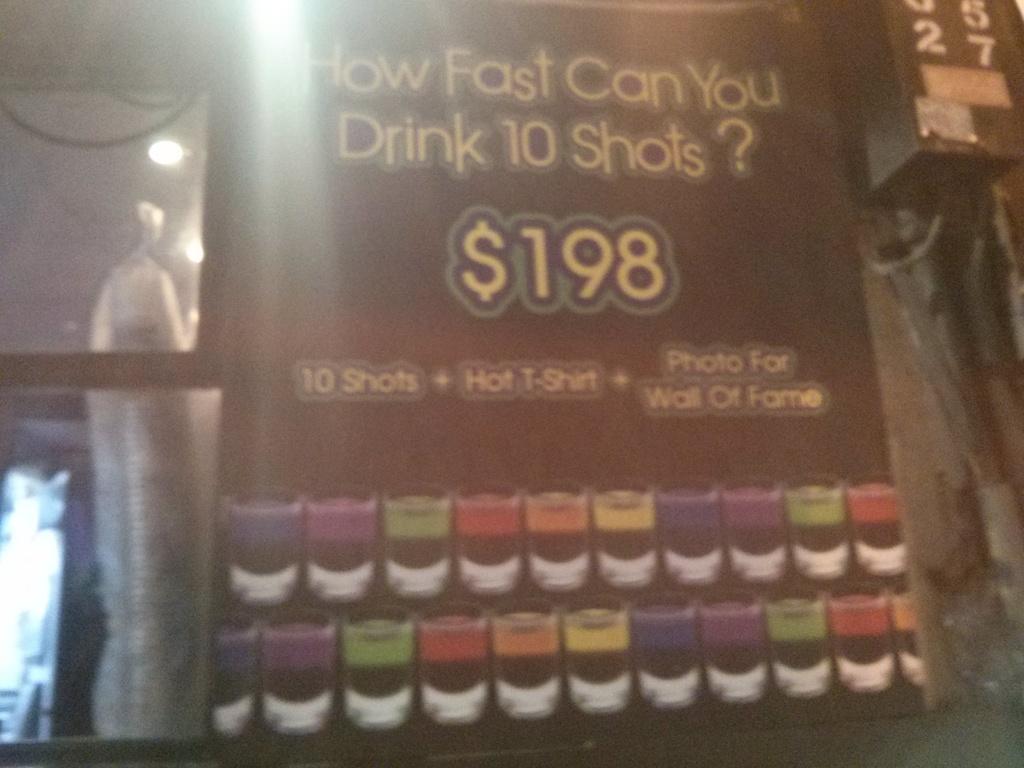What is the second thing you get for $198?
Offer a terse response. Hot t-shirt. 